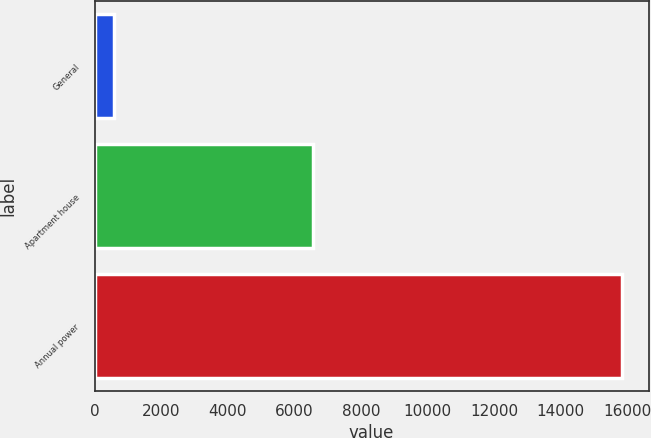Convert chart to OTSL. <chart><loc_0><loc_0><loc_500><loc_500><bar_chart><fcel>General<fcel>Apartment house<fcel>Annual power<nl><fcel>594<fcel>6574<fcel>15848<nl></chart> 